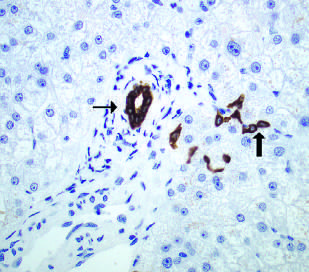what are stained here with an immunohistochemical stain for cytokeratin 7?
Answer the question using a single word or phrase. Bile duct cells and canals of hering 